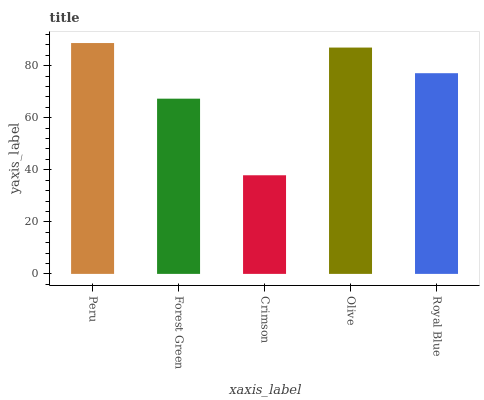Is Crimson the minimum?
Answer yes or no. Yes. Is Peru the maximum?
Answer yes or no. Yes. Is Forest Green the minimum?
Answer yes or no. No. Is Forest Green the maximum?
Answer yes or no. No. Is Peru greater than Forest Green?
Answer yes or no. Yes. Is Forest Green less than Peru?
Answer yes or no. Yes. Is Forest Green greater than Peru?
Answer yes or no. No. Is Peru less than Forest Green?
Answer yes or no. No. Is Royal Blue the high median?
Answer yes or no. Yes. Is Royal Blue the low median?
Answer yes or no. Yes. Is Peru the high median?
Answer yes or no. No. Is Forest Green the low median?
Answer yes or no. No. 